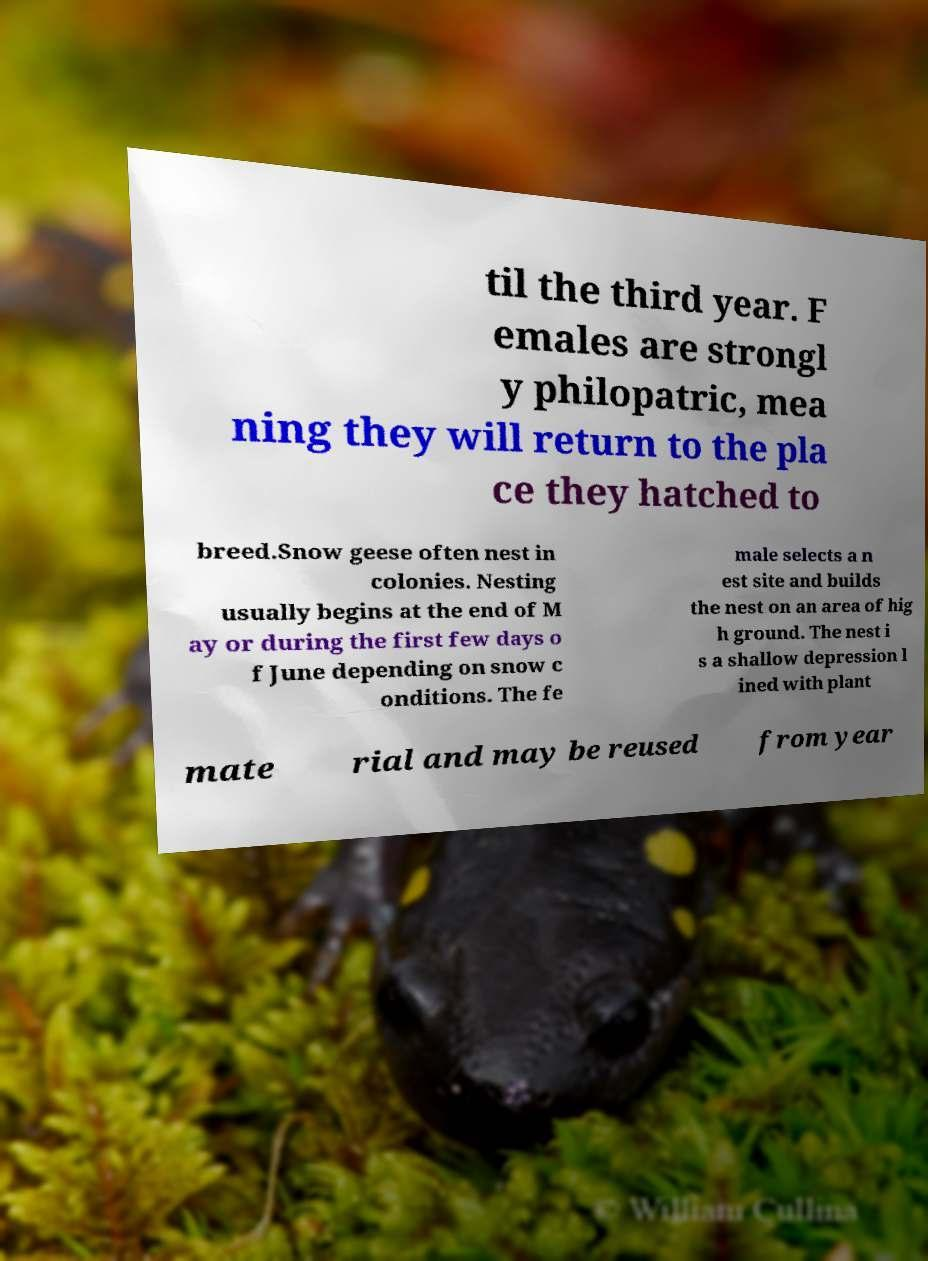I need the written content from this picture converted into text. Can you do that? til the third year. F emales are strongl y philopatric, mea ning they will return to the pla ce they hatched to breed.Snow geese often nest in colonies. Nesting usually begins at the end of M ay or during the first few days o f June depending on snow c onditions. The fe male selects a n est site and builds the nest on an area of hig h ground. The nest i s a shallow depression l ined with plant mate rial and may be reused from year 